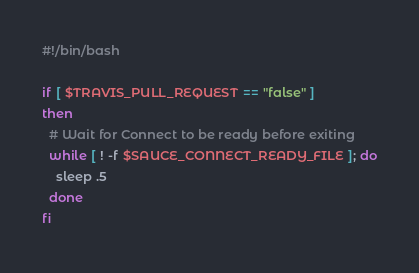Convert code to text. <code><loc_0><loc_0><loc_500><loc_500><_Bash_>#!/bin/bash

if [ $TRAVIS_PULL_REQUEST == "false" ]
then
  # Wait for Connect to be ready before exiting
  while [ ! -f $SAUCE_CONNECT_READY_FILE ]; do
    sleep .5
  done
fi
</code> 